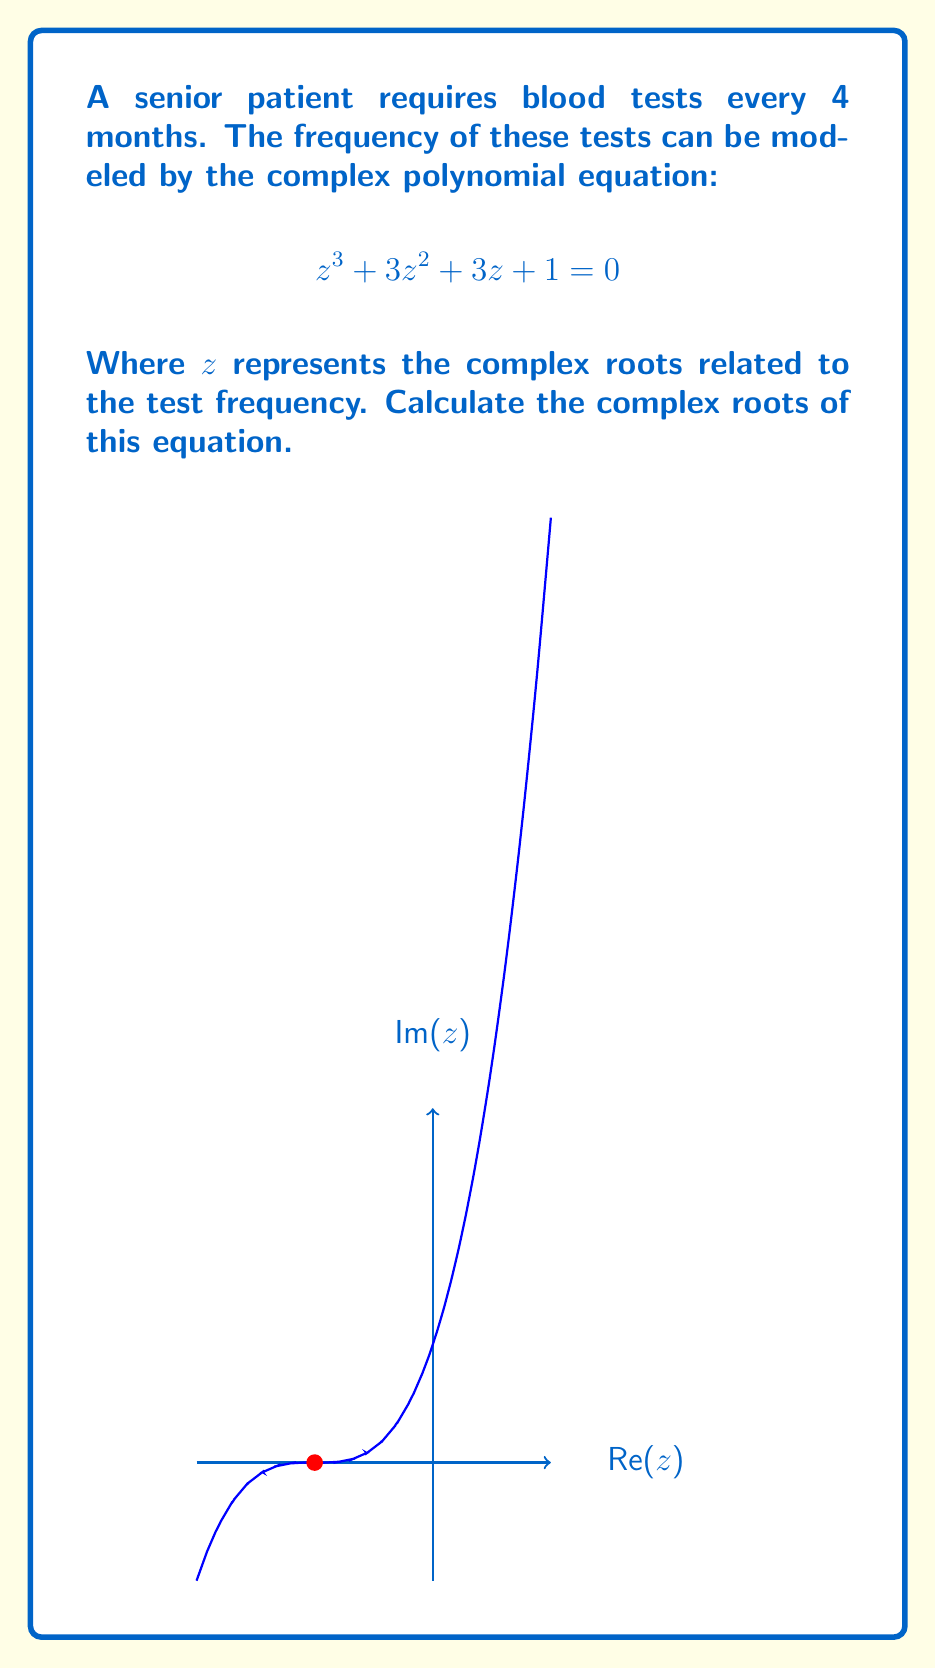Help me with this question. To solve this equation, we can follow these steps:

1) First, recognize that this is a cubic equation in the form $z^3 + 3z^2 + 3z + 1 = 0$.

2) This equation can be factored as $(z + 1)^3 = 0$.

3) The factor $(z + 1)$ is repeated three times, which means the equation has a triple root.

4) To find the root, solve $z + 1 = 0$:

   $$z = -1$$

5) Since this is a triple root, all three solutions are the same: $z_1 = z_2 = z_3 = -1$.

6) In the context of the blood test frequency, the real part of the root (-1) represents a shift in the periodic function, while the imaginary part (0) indicates no oscillation in the complex plane.

This triple root at -1 suggests a stable, consistent testing schedule for the senior patient, aligning with the described 4-month interval.
Answer: $z_1 = z_2 = z_3 = -1$ 